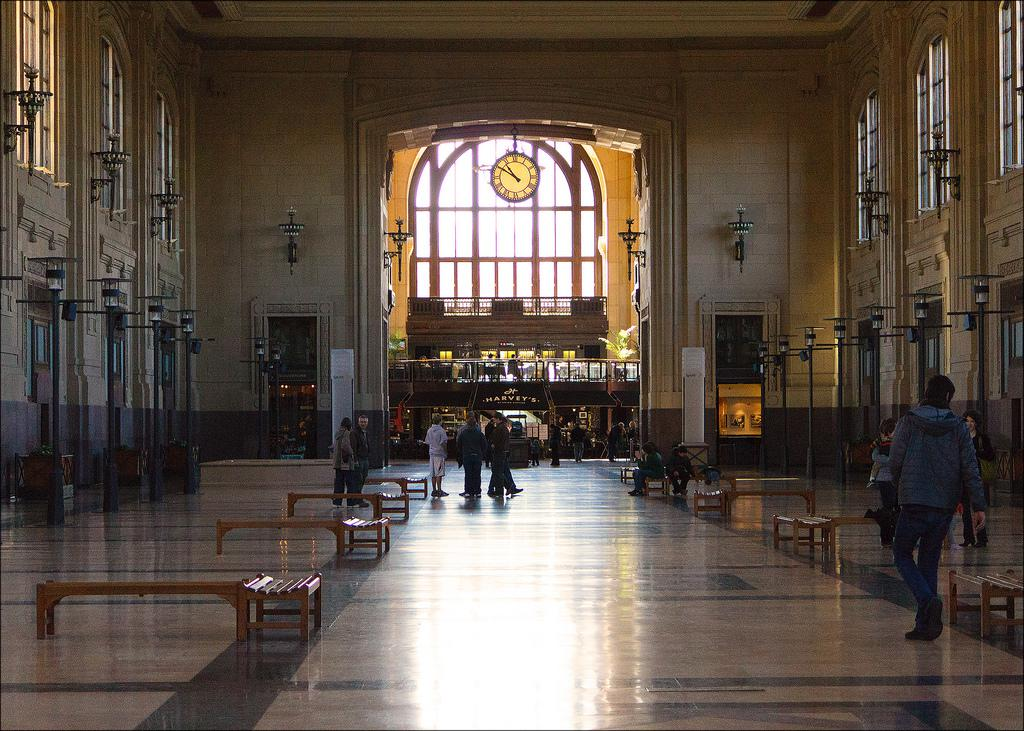Question: what time does the clock read?
Choices:
A. 12:00.
B. 1:45.
C. 2:15.
D. 11:40.
Answer with the letter. Answer: D Question: where is the picture taken?
Choices:
A. A police station.
B. A train station.
C. An airport.
D. A subway station.
Answer with the letter. Answer: B Question: what is the floor made of?
Choices:
A. Wood.
B. Carpet.
C. Concrete.
D. Dirt.
Answer with the letter. Answer: C Question: how many benches are there?
Choices:
A. Two.
B. Three.
C. Eight.
D. Four.
Answer with the letter. Answer: C Question: what are the benches made of?
Choices:
A. Metal.
B. Plastic.
C. Ceramic.
D. Wood.
Answer with the letter. Answer: D Question: how many windows are there?
Choices:
A. Two.
B. Seven.
C. Three.
D. Four.
Answer with the letter. Answer: B Question: what color are the walls?
Choices:
A. White.
B. Blue.
C. Beige.
D. Yellow.
Answer with the letter. Answer: C Question: where is this located?
Choices:
A. A bus station.
B. A marina.
C. A train station.
D. An airport.
Answer with the letter. Answer: C Question: where is this located?
Choices:
A. The lobby.
B. Restroom.
C. Hallway.
D. Hotel room.
Answer with the letter. Answer: A Question: where are the sconces?
Choices:
A. Next to the fireplace.
B. On the table.
C. On the wall.
D. Above the counter.
Answer with the letter. Answer: C Question: how would one describe the floors?
Choices:
A. Clean.
B. Beautiful.
C. Shiny.
D. Ugly.
Answer with the letter. Answer: C Question: what is in the scene?
Choices:
A. A horse.
B. A clock.
C. A lighthouse.
D. A boat.
Answer with the letter. Answer: B Question: what is shiny?
Choices:
A. Floor.
B. Crystals.
C. Wineglasses.
D. Window.
Answer with the letter. Answer: A Question: what is the sunlight reflected on?
Choices:
A. The picture.
B. The ground.
C. The floor.
D. The child.
Answer with the letter. Answer: C Question: where is a bright light coming from?
Choices:
A. The sun.
B. The lamp.
C. The window.
D. Window.
Answer with the letter. Answer: D Question: where are benches?
Choices:
A. In indoor space.
B. In the park.
C. On the porch.
D. Outside.
Answer with the letter. Answer: A Question: where is light reflection?
Choices:
A. In the window.
B. On the roof.
C. On floor.
D. In the room.
Answer with the letter. Answer: C 